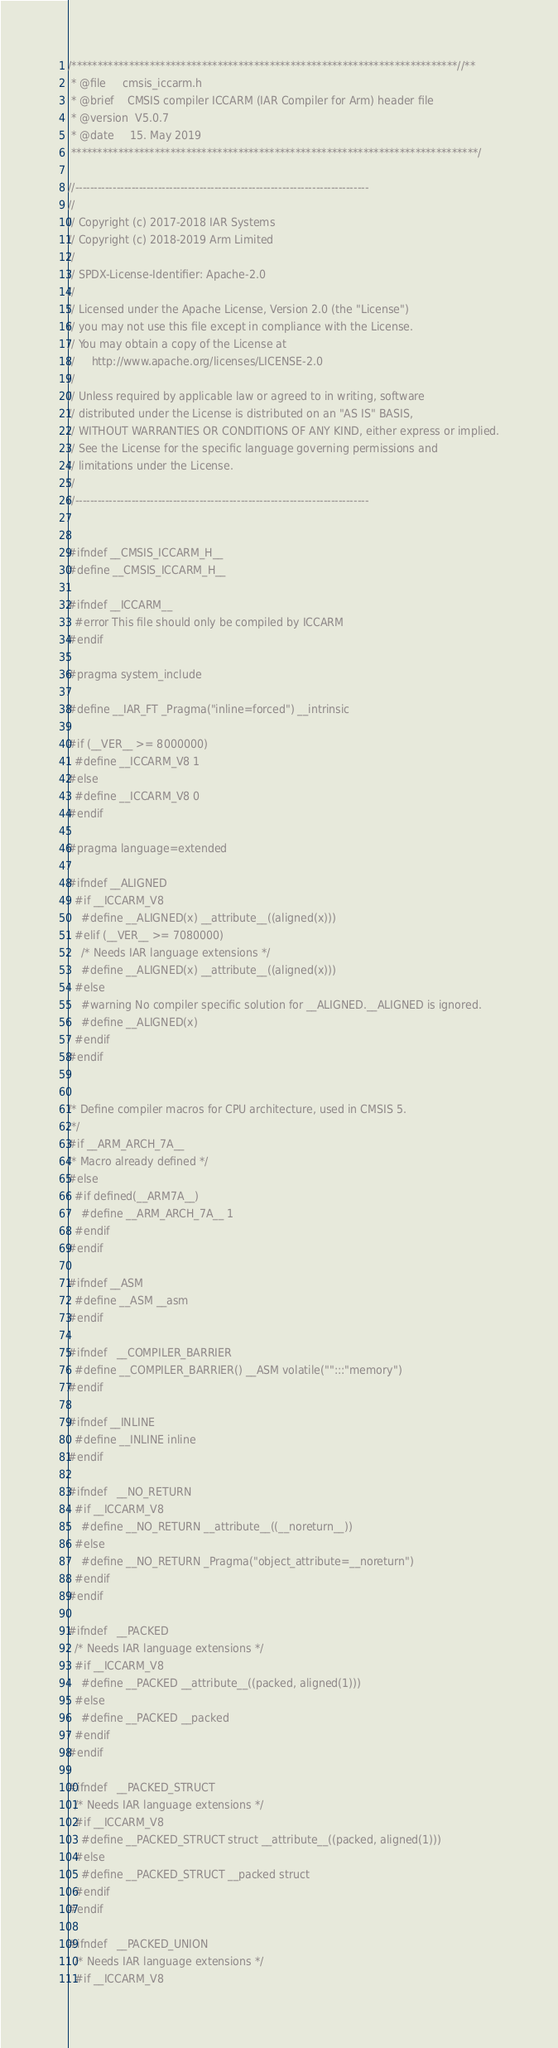<code> <loc_0><loc_0><loc_500><loc_500><_C_>/**************************************************************************//**
 * @file     cmsis_iccarm.h
 * @brief    CMSIS compiler ICCARM (IAR Compiler for Arm) header file
 * @version  V5.0.7
 * @date     15. May 2019
 ******************************************************************************/

//------------------------------------------------------------------------------
//
// Copyright (c) 2017-2018 IAR Systems
// Copyright (c) 2018-2019 Arm Limited 
//
// SPDX-License-Identifier: Apache-2.0
//
// Licensed under the Apache License, Version 2.0 (the "License")
// you may not use this file except in compliance with the License.
// You may obtain a copy of the License at
//     http://www.apache.org/licenses/LICENSE-2.0
//
// Unless required by applicable law or agreed to in writing, software
// distributed under the License is distributed on an "AS IS" BASIS,
// WITHOUT WARRANTIES OR CONDITIONS OF ANY KIND, either express or implied.
// See the License for the specific language governing permissions and
// limitations under the License.
//
//------------------------------------------------------------------------------


#ifndef __CMSIS_ICCARM_H__
#define __CMSIS_ICCARM_H__

#ifndef __ICCARM__
  #error This file should only be compiled by ICCARM
#endif

#pragma system_include

#define __IAR_FT _Pragma("inline=forced") __intrinsic

#if (__VER__ >= 8000000)
  #define __ICCARM_V8 1
#else
  #define __ICCARM_V8 0
#endif

#pragma language=extended

#ifndef __ALIGNED
  #if __ICCARM_V8
    #define __ALIGNED(x) __attribute__((aligned(x)))
  #elif (__VER__ >= 7080000)
    /* Needs IAR language extensions */
    #define __ALIGNED(x) __attribute__((aligned(x)))
  #else
    #warning No compiler specific solution for __ALIGNED.__ALIGNED is ignored.
    #define __ALIGNED(x)
  #endif
#endif


/* Define compiler macros for CPU architecture, used in CMSIS 5.
 */
#if __ARM_ARCH_7A__
/* Macro already defined */
#else
  #if defined(__ARM7A__)
    #define __ARM_ARCH_7A__ 1
  #endif
#endif

#ifndef __ASM
  #define __ASM __asm
#endif

#ifndef   __COMPILER_BARRIER
  #define __COMPILER_BARRIER() __ASM volatile("":::"memory")
#endif

#ifndef __INLINE
  #define __INLINE inline
#endif

#ifndef   __NO_RETURN
  #if __ICCARM_V8
    #define __NO_RETURN __attribute__((__noreturn__))
  #else
    #define __NO_RETURN _Pragma("object_attribute=__noreturn")
  #endif
#endif

#ifndef   __PACKED
  /* Needs IAR language extensions */
  #if __ICCARM_V8
    #define __PACKED __attribute__((packed, aligned(1)))
  #else
    #define __PACKED __packed
  #endif
#endif

#ifndef   __PACKED_STRUCT
  /* Needs IAR language extensions */
  #if __ICCARM_V8
    #define __PACKED_STRUCT struct __attribute__((packed, aligned(1)))
  #else
    #define __PACKED_STRUCT __packed struct
  #endif
#endif

#ifndef   __PACKED_UNION
  /* Needs IAR language extensions */
  #if __ICCARM_V8</code> 